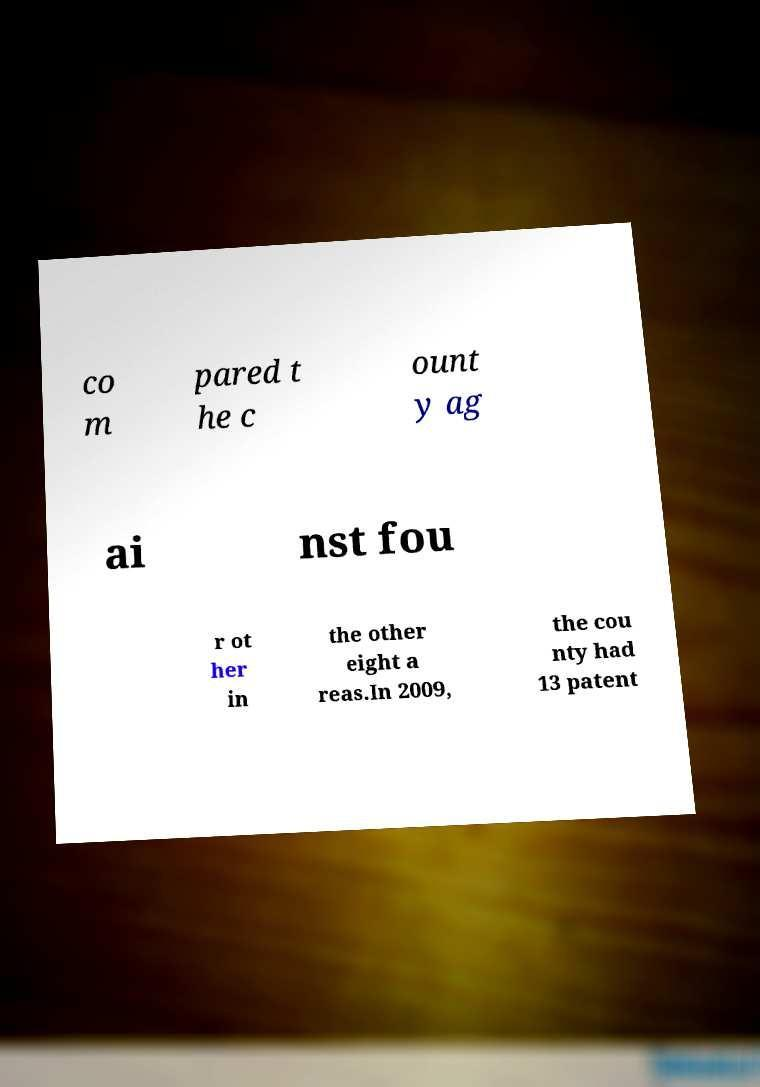Please identify and transcribe the text found in this image. co m pared t he c ount y ag ai nst fou r ot her in the other eight a reas.In 2009, the cou nty had 13 patent 